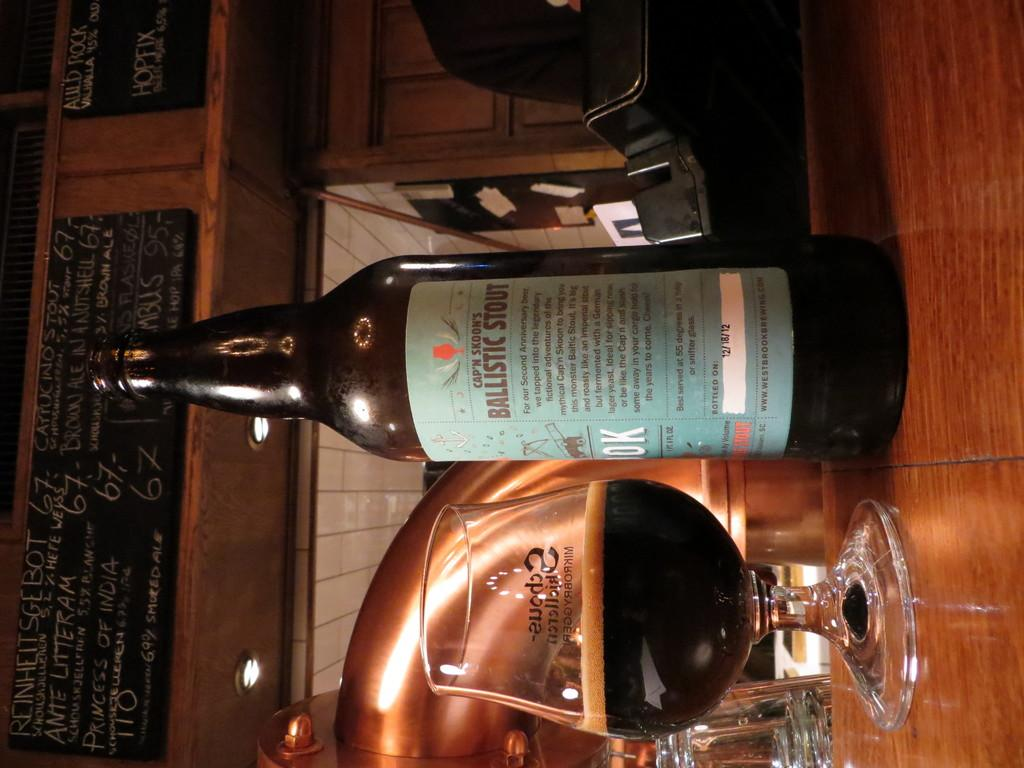<image>
Describe the image concisely. Glass of Ballistic Stout on the counter next to the bottle. 